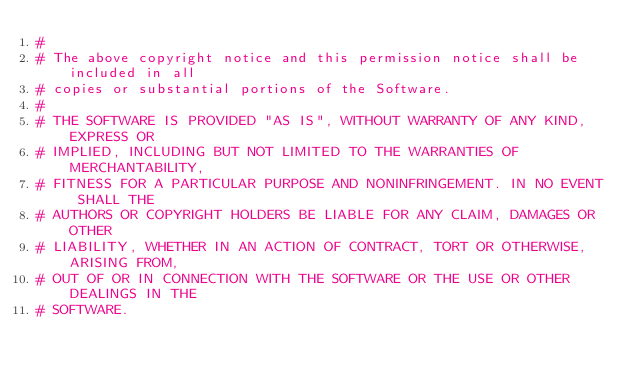<code> <loc_0><loc_0><loc_500><loc_500><_Python_>#
# The above copyright notice and this permission notice shall be included in all
# copies or substantial portions of the Software.
#
# THE SOFTWARE IS PROVIDED "AS IS", WITHOUT WARRANTY OF ANY KIND, EXPRESS OR
# IMPLIED, INCLUDING BUT NOT LIMITED TO THE WARRANTIES OF MERCHANTABILITY,
# FITNESS FOR A PARTICULAR PURPOSE AND NONINFRINGEMENT. IN NO EVENT SHALL THE
# AUTHORS OR COPYRIGHT HOLDERS BE LIABLE FOR ANY CLAIM, DAMAGES OR OTHER
# LIABILITY, WHETHER IN AN ACTION OF CONTRACT, TORT OR OTHERWISE, ARISING FROM,
# OUT OF OR IN CONNECTION WITH THE SOFTWARE OR THE USE OR OTHER DEALINGS IN THE
# SOFTWARE.

</code> 